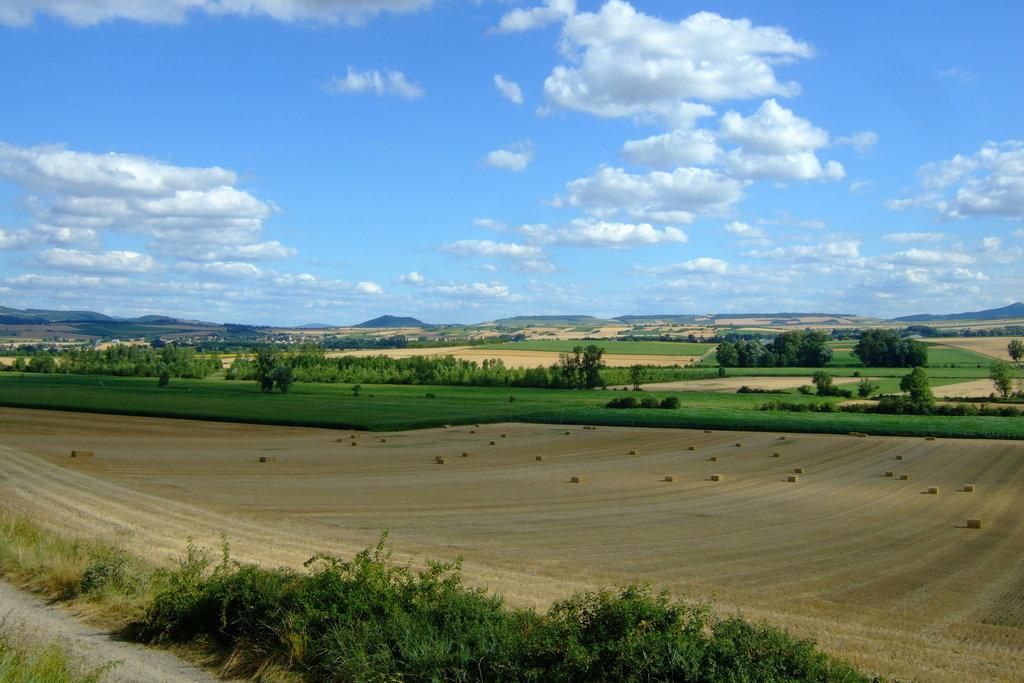What type of surface is visible on the ground in the image? The ground with grass is visible in the image. What other natural elements can be seen in the image? There are plants in the image. What objects are present on the ground? There are objects on the ground. What is visible in the background of the image? The sky is visible in the image. What can be observed in the sky? Clouds are present in the sky. What type of operation is being performed on the plants in the image? There is no operation being performed on the plants in the image; they are simply present in the scene. 